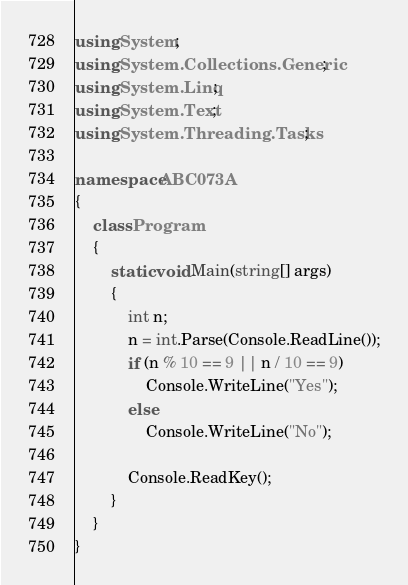Convert code to text. <code><loc_0><loc_0><loc_500><loc_500><_C#_>using System;
using System.Collections.Generic;
using System.Linq;
using System.Text;
using System.Threading.Tasks;

namespace ABC073A
{
    class Program
    {
        static void Main(string[] args)
        {
            int n;
            n = int.Parse(Console.ReadLine());
            if (n % 10 == 9 || n / 10 == 9)
                Console.WriteLine("Yes");
            else
                Console.WriteLine("No");

            Console.ReadKey();
        }
    }
}
</code> 